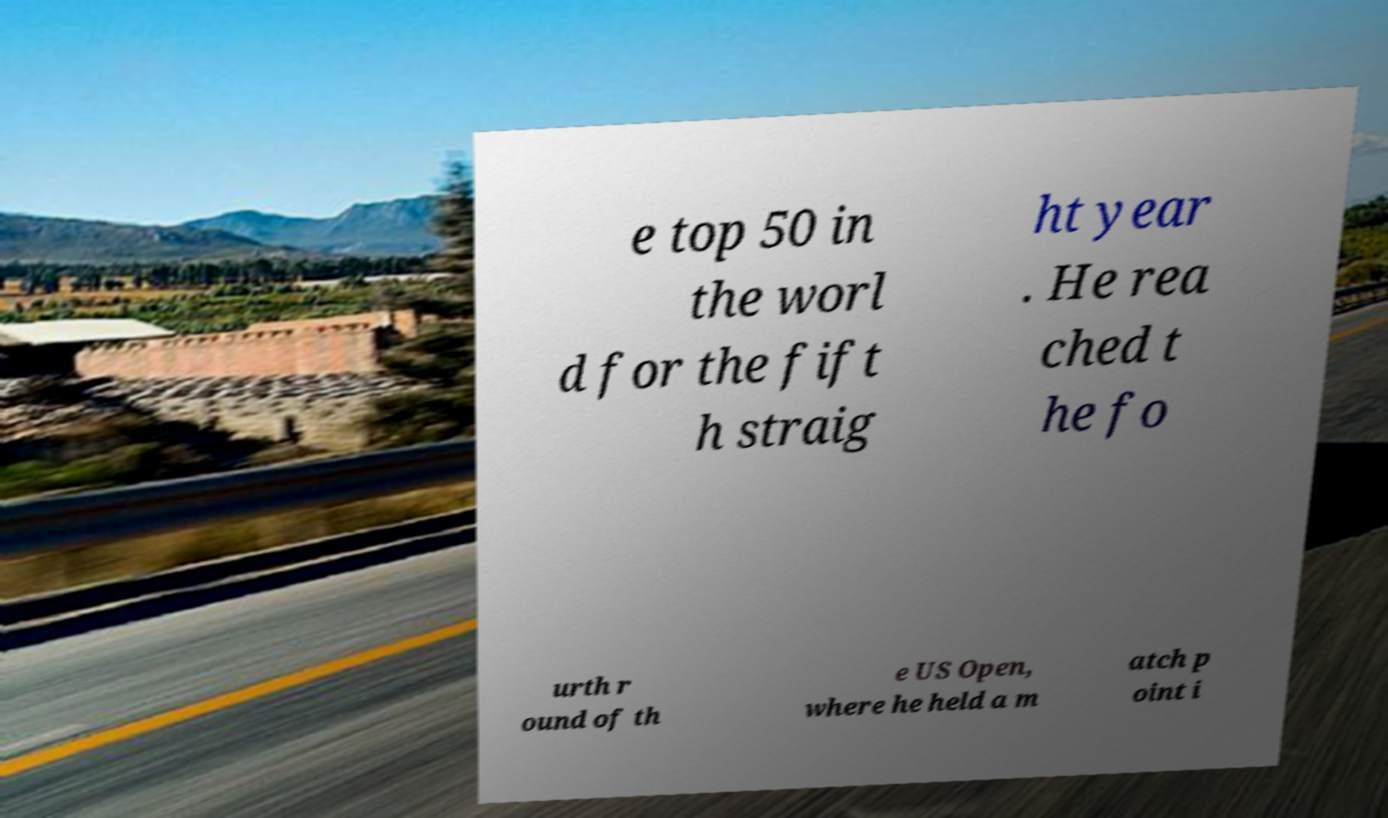I need the written content from this picture converted into text. Can you do that? e top 50 in the worl d for the fift h straig ht year . He rea ched t he fo urth r ound of th e US Open, where he held a m atch p oint i 